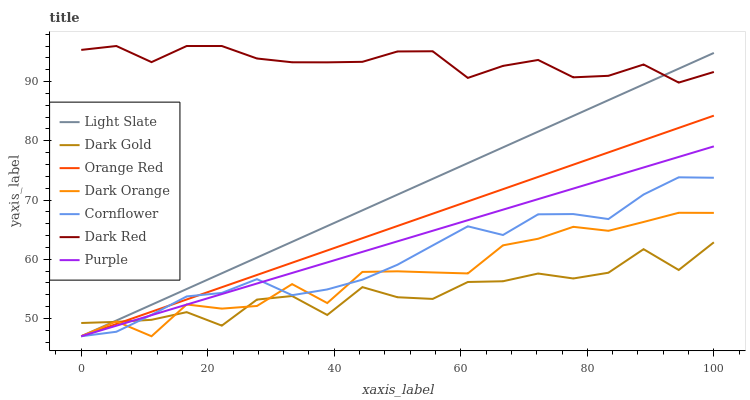Does Dark Gold have the minimum area under the curve?
Answer yes or no. Yes. Does Dark Red have the maximum area under the curve?
Answer yes or no. Yes. Does Cornflower have the minimum area under the curve?
Answer yes or no. No. Does Cornflower have the maximum area under the curve?
Answer yes or no. No. Is Purple the smoothest?
Answer yes or no. Yes. Is Dark Gold the roughest?
Answer yes or no. Yes. Is Cornflower the smoothest?
Answer yes or no. No. Is Cornflower the roughest?
Answer yes or no. No. Does Dark Orange have the lowest value?
Answer yes or no. Yes. Does Dark Red have the lowest value?
Answer yes or no. No. Does Dark Red have the highest value?
Answer yes or no. Yes. Does Cornflower have the highest value?
Answer yes or no. No. Is Cornflower less than Dark Red?
Answer yes or no. Yes. Is Dark Red greater than Cornflower?
Answer yes or no. Yes. Does Light Slate intersect Dark Orange?
Answer yes or no. Yes. Is Light Slate less than Dark Orange?
Answer yes or no. No. Is Light Slate greater than Dark Orange?
Answer yes or no. No. Does Cornflower intersect Dark Red?
Answer yes or no. No. 